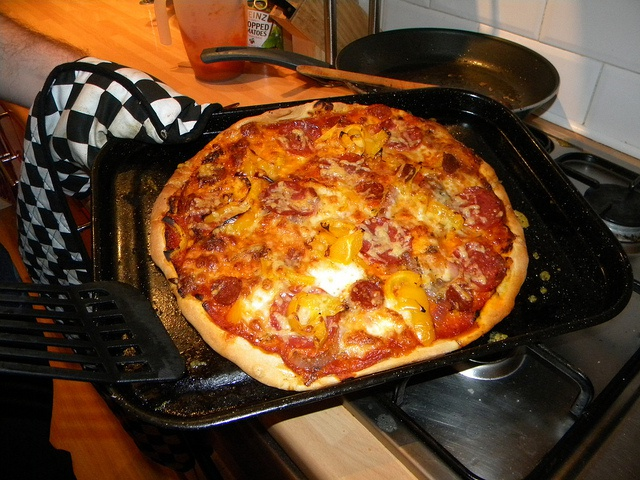Describe the objects in this image and their specific colors. I can see pizza in brown, red, and orange tones, oven in brown, black, and gray tones, bowl in brown, black, and maroon tones, people in brown, gray, and salmon tones, and bottle in brown, black, maroon, darkgray, and olive tones in this image. 